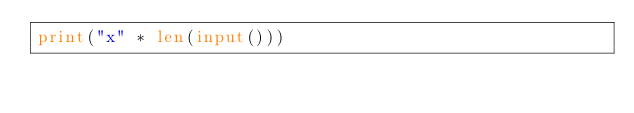Convert code to text. <code><loc_0><loc_0><loc_500><loc_500><_Python_>print("x" * len(input()))</code> 